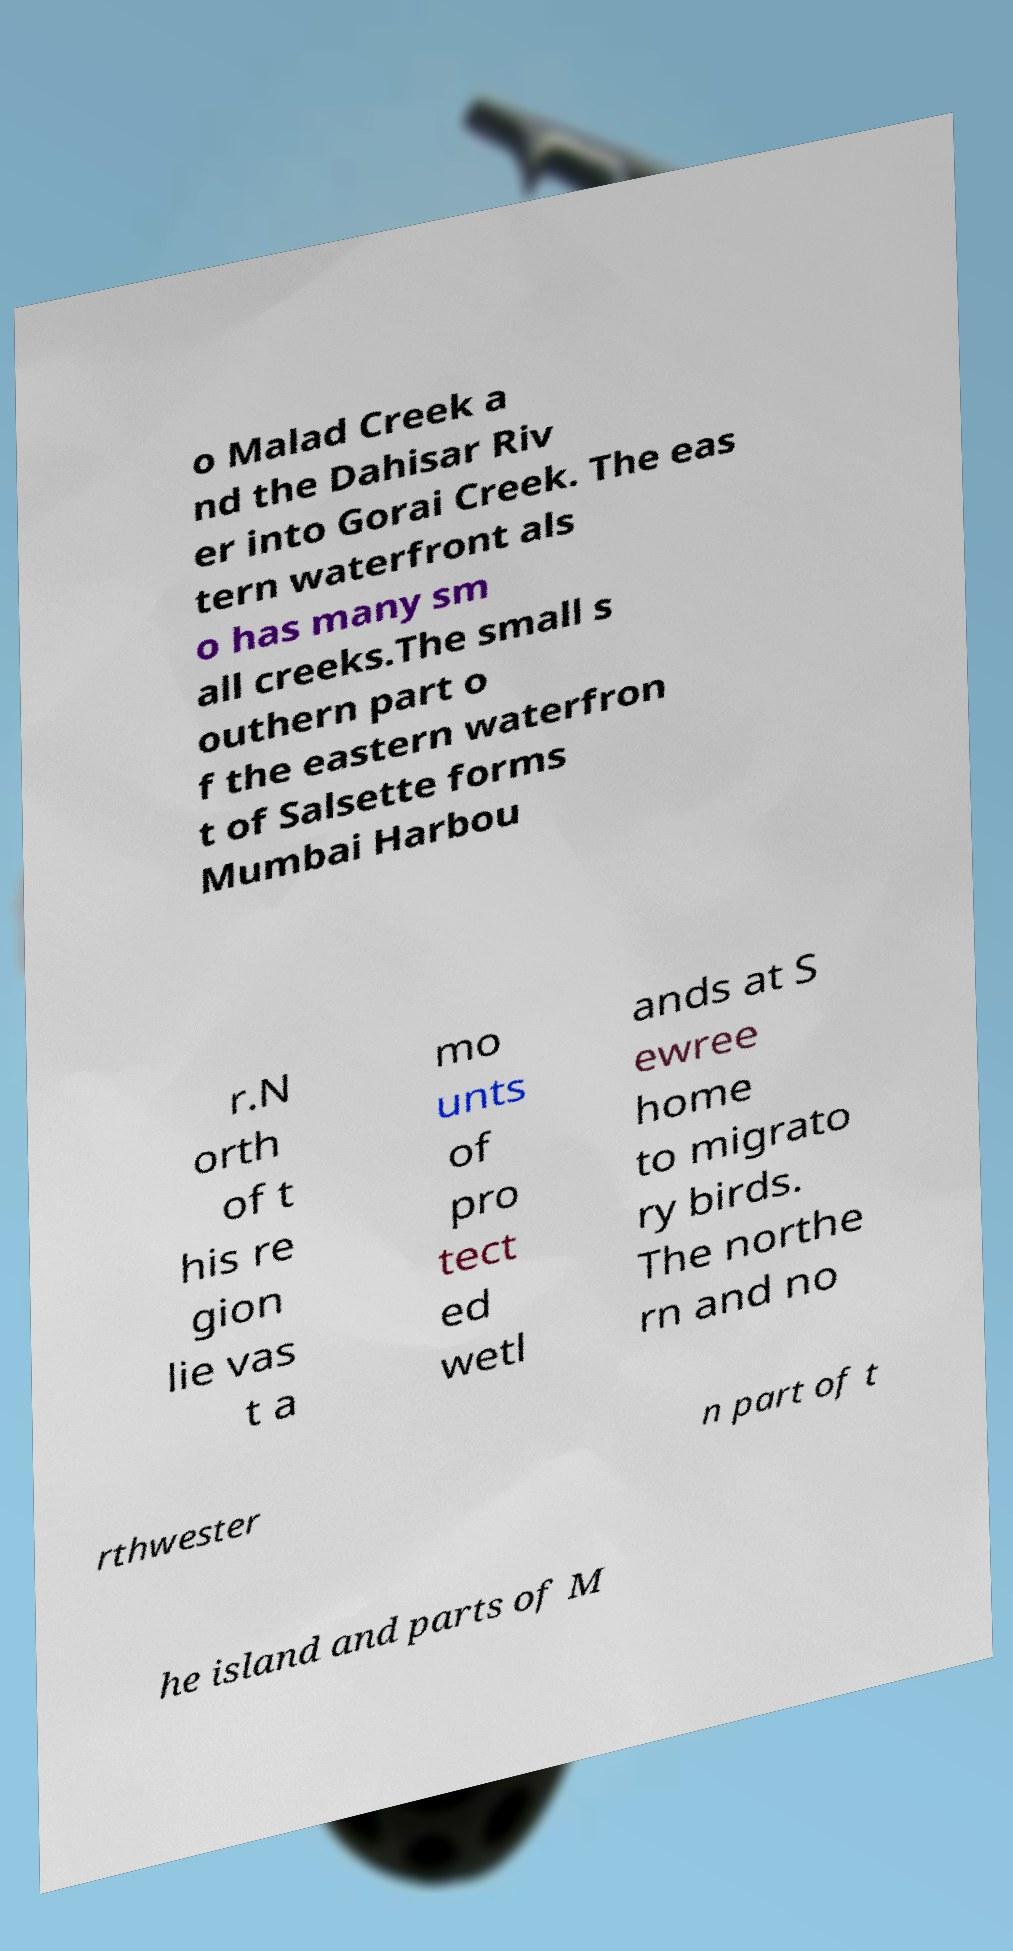I need the written content from this picture converted into text. Can you do that? o Malad Creek a nd the Dahisar Riv er into Gorai Creek. The eas tern waterfront als o has many sm all creeks.The small s outhern part o f the eastern waterfron t of Salsette forms Mumbai Harbou r.N orth of t his re gion lie vas t a mo unts of pro tect ed wetl ands at S ewree home to migrato ry birds. The northe rn and no rthwester n part of t he island and parts of M 